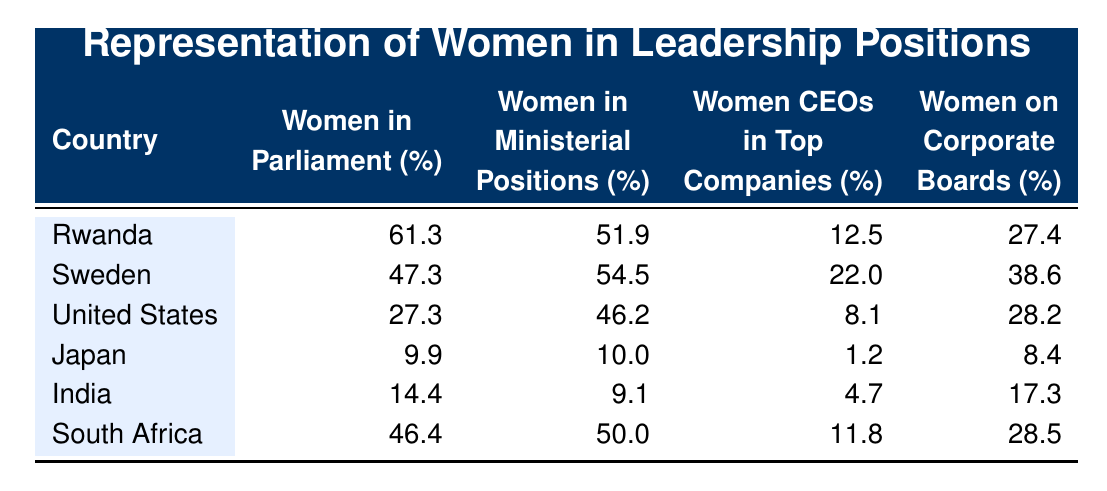What percentage of women in Parliament does Rwanda have? Rwanda has 61.3% of women in Parliament according to the table.
Answer: 61.3% Which country has the highest percentage of women in ministerial positions? Sweden has the highest percentage of women in ministerial positions at 54.5%, which is greater than all other listed countries.
Answer: Sweden What is the difference in the percentage of women CEOs between South Africa and Japan? South Africa has 11.8% of women CEOs while Japan has 1.2%. The difference is calculated as 11.8% - 1.2% = 10.6%.
Answer: 10.6% Is it true that the United States has more women on corporate boards than Rwanda? No, the United States has 28.2% women on corporate boards, while Rwanda has 27.4%. Thus, the statement is false.
Answer: No What is the average percentage of women in Parliament across all countries listed? To find the average, first sum up the percentages: 61.3 + 47.3 + 27.3 + 9.9 + 14.4 + 46.4 = 206.0. There are 6 countries, so the average is 206.0 / 6 = 34.33%.
Answer: 34.33% Which country has the lowest representation of women CEOs in top companies? Japan has the lowest representation of women CEOs at 1.2%, which is the least among all listed countries.
Answer: Japan What percentage of women on corporate boards does India have compared to Sweden? India has 17.3% of women on corporate boards, whereas Sweden has 38.6%. Therefore, Sweden has a higher percentage of women on corporate boards.
Answer: Sweden Does Rwanda have a higher percentage of women in ministerial positions than South Africa? Yes, Rwanda has 51.9% women in ministerial positions compared to 50% in South Africa, making the statement true.
Answer: Yes 